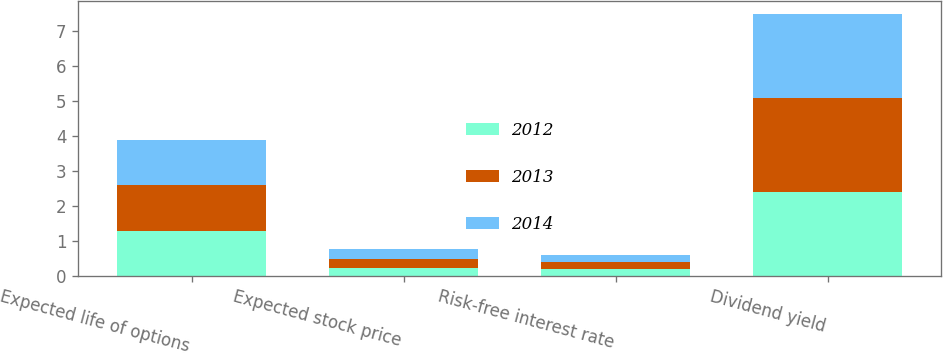<chart> <loc_0><loc_0><loc_500><loc_500><stacked_bar_chart><ecel><fcel>Expected life of options<fcel>Expected stock price<fcel>Risk-free interest rate<fcel>Dividend yield<nl><fcel>2012<fcel>1.3<fcel>0.24<fcel>0.2<fcel>2.4<nl><fcel>2013<fcel>1.3<fcel>0.26<fcel>0.2<fcel>2.7<nl><fcel>2014<fcel>1.3<fcel>0.29<fcel>0.2<fcel>2.4<nl></chart> 